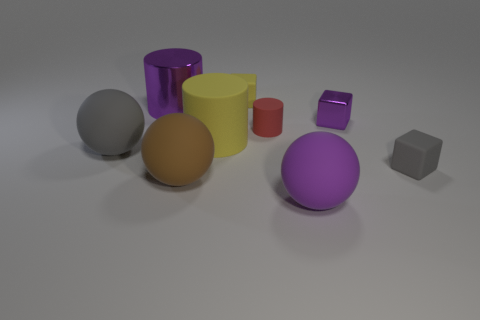Subtract all yellow matte cylinders. How many cylinders are left? 2 Subtract 1 cylinders. How many cylinders are left? 2 Add 1 yellow matte cylinders. How many objects exist? 10 Subtract all cylinders. How many objects are left? 6 Subtract all red blocks. Subtract all purple spheres. How many blocks are left? 3 Subtract all green metallic cubes. Subtract all metal blocks. How many objects are left? 8 Add 4 tiny red cylinders. How many tiny red cylinders are left? 5 Add 2 tiny yellow matte objects. How many tiny yellow matte objects exist? 3 Subtract 0 green cylinders. How many objects are left? 9 